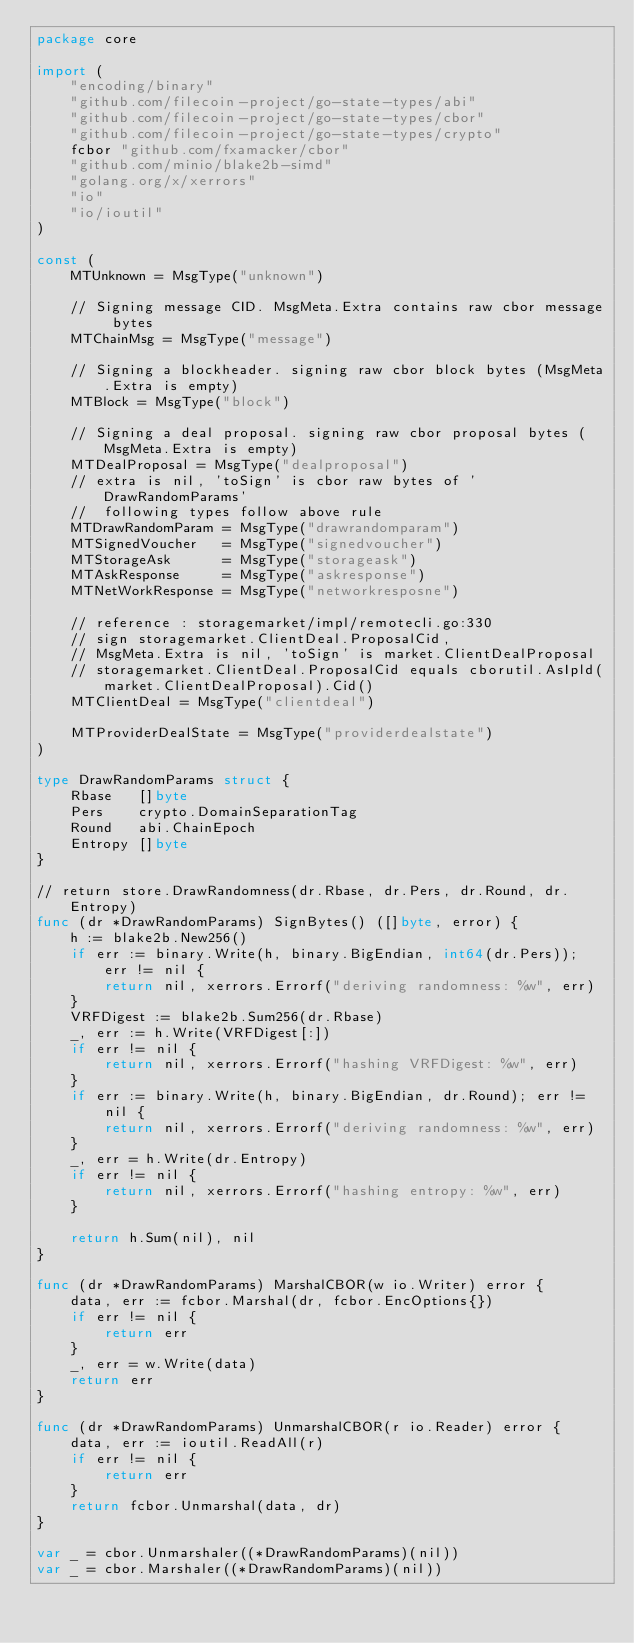<code> <loc_0><loc_0><loc_500><loc_500><_Go_>package core

import (
	"encoding/binary"
	"github.com/filecoin-project/go-state-types/abi"
	"github.com/filecoin-project/go-state-types/cbor"
	"github.com/filecoin-project/go-state-types/crypto"
	fcbor "github.com/fxamacker/cbor"
	"github.com/minio/blake2b-simd"
	"golang.org/x/xerrors"
	"io"
	"io/ioutil"
)

const (
	MTUnknown = MsgType("unknown")

	// Signing message CID. MsgMeta.Extra contains raw cbor message bytes
	MTChainMsg = MsgType("message")

	// Signing a blockheader. signing raw cbor block bytes (MsgMeta.Extra is empty)
	MTBlock = MsgType("block")

	// Signing a deal proposal. signing raw cbor proposal bytes (MsgMeta.Extra is empty)
	MTDealProposal = MsgType("dealproposal")
	// extra is nil, 'toSign' is cbor raw bytes of 'DrawRandomParams'
	//  following types follow above rule
	MTDrawRandomParam = MsgType("drawrandomparam")
	MTSignedVoucher   = MsgType("signedvoucher")
	MTStorageAsk      = MsgType("storageask")
	MTAskResponse     = MsgType("askresponse")
	MTNetWorkResponse = MsgType("networkresposne")

	// reference : storagemarket/impl/remotecli.go:330
	// sign storagemarket.ClientDeal.ProposalCid,
	// MsgMeta.Extra is nil, 'toSign' is market.ClientDealProposal
	// storagemarket.ClientDeal.ProposalCid equals cborutil.AsIpld(market.ClientDealProposal).Cid()
	MTClientDeal = MsgType("clientdeal")

	MTProviderDealState = MsgType("providerdealstate")
)

type DrawRandomParams struct {
	Rbase   []byte
	Pers    crypto.DomainSeparationTag
	Round   abi.ChainEpoch
	Entropy []byte
}

// return store.DrawRandomness(dr.Rbase, dr.Pers, dr.Round, dr.Entropy)
func (dr *DrawRandomParams) SignBytes() ([]byte, error) {
	h := blake2b.New256()
	if err := binary.Write(h, binary.BigEndian, int64(dr.Pers)); err != nil {
		return nil, xerrors.Errorf("deriving randomness: %w", err)
	}
	VRFDigest := blake2b.Sum256(dr.Rbase)
	_, err := h.Write(VRFDigest[:])
	if err != nil {
		return nil, xerrors.Errorf("hashing VRFDigest: %w", err)
	}
	if err := binary.Write(h, binary.BigEndian, dr.Round); err != nil {
		return nil, xerrors.Errorf("deriving randomness: %w", err)
	}
	_, err = h.Write(dr.Entropy)
	if err != nil {
		return nil, xerrors.Errorf("hashing entropy: %w", err)
	}

	return h.Sum(nil), nil
}

func (dr *DrawRandomParams) MarshalCBOR(w io.Writer) error {
	data, err := fcbor.Marshal(dr, fcbor.EncOptions{})
	if err != nil {
		return err
	}
	_, err = w.Write(data)
	return err
}

func (dr *DrawRandomParams) UnmarshalCBOR(r io.Reader) error {
	data, err := ioutil.ReadAll(r)
	if err != nil {
		return err
	}
	return fcbor.Unmarshal(data, dr)
}

var _ = cbor.Unmarshaler((*DrawRandomParams)(nil))
var _ = cbor.Marshaler((*DrawRandomParams)(nil))
</code> 